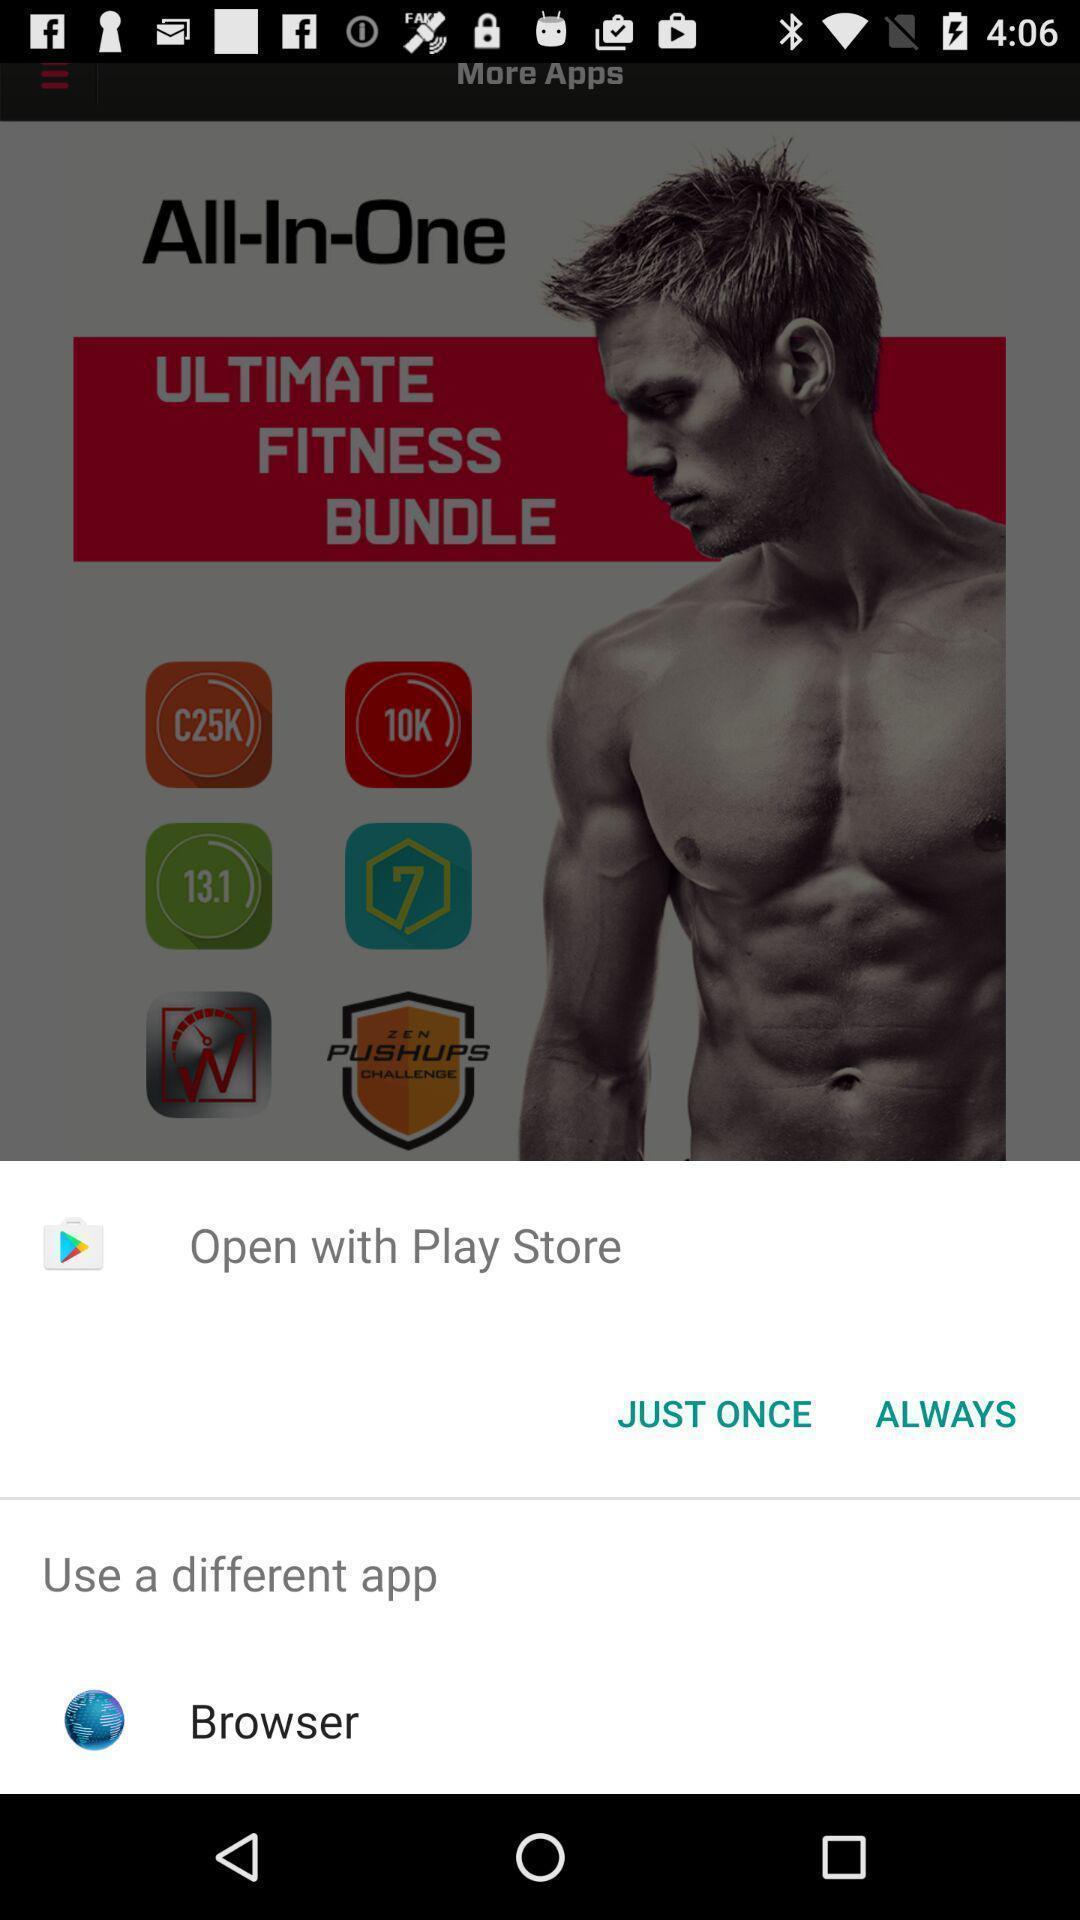Describe the content in this image. Pop-up asking to open app via different browsers. 